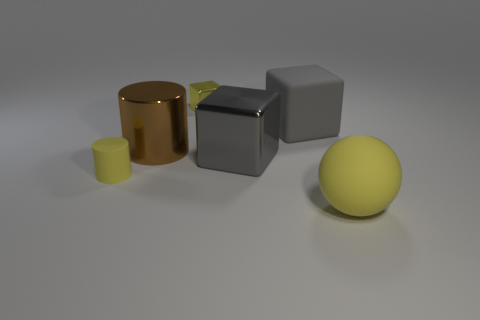Is the color of the large sphere the same as the small metallic object?
Your answer should be very brief. Yes. Are there fewer gray things in front of the large cylinder than big yellow balls?
Your answer should be very brief. No. There is a cylinder that is behind the small rubber thing; what is its color?
Provide a succinct answer. Brown. There is a small yellow shiny thing; what shape is it?
Your answer should be compact. Cube. There is a big metal object that is to the right of the tiny yellow object to the right of the yellow cylinder; are there any matte balls that are to the right of it?
Your response must be concise. Yes. The large rubber ball on the right side of the yellow rubber object that is to the left of the big matte object that is on the right side of the large rubber block is what color?
Make the answer very short. Yellow. There is another object that is the same shape as the tiny rubber object; what material is it?
Your answer should be very brief. Metal. There is a metallic cube in front of the thing behind the gray matte block; what is its size?
Offer a terse response. Large. What is the material of the yellow object behind the big gray shiny block?
Offer a terse response. Metal. There is a gray thing that is the same material as the yellow cylinder; what is its size?
Your answer should be compact. Large. 